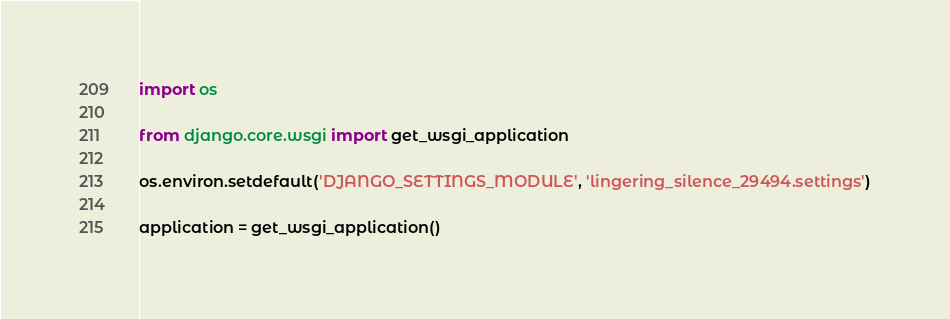<code> <loc_0><loc_0><loc_500><loc_500><_Python_>import os

from django.core.wsgi import get_wsgi_application

os.environ.setdefault('DJANGO_SETTINGS_MODULE', 'lingering_silence_29494.settings')

application = get_wsgi_application()
</code> 